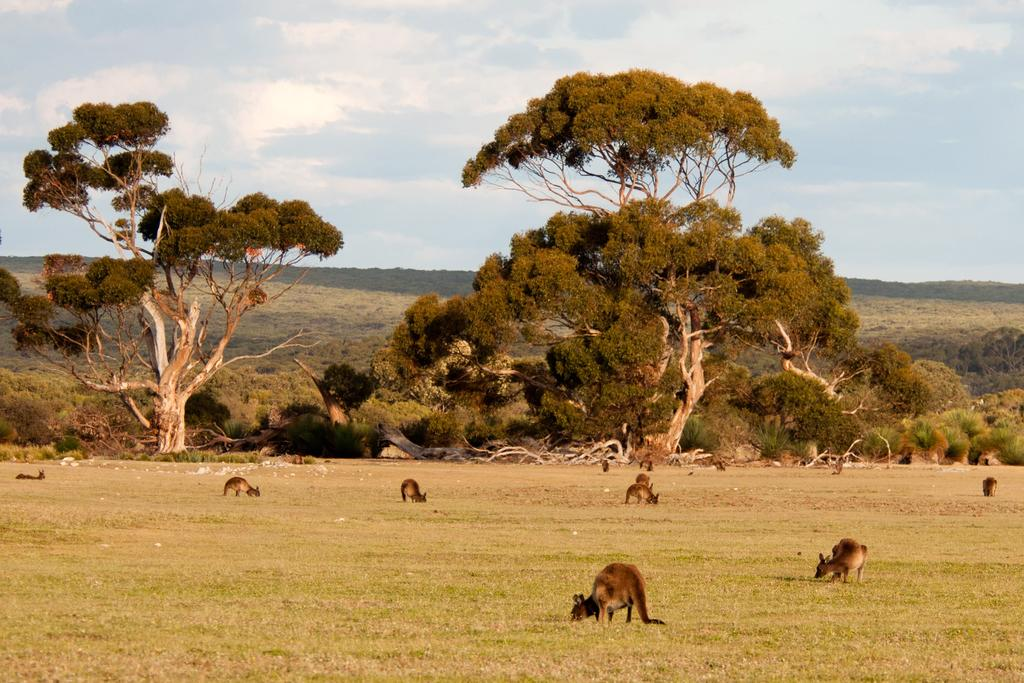What is the main subject of the image? There is a group of animals in the image. How are the animals positioned in the image? The animals are standing on the ground. What can be seen in the background of the image? There is a group of trees and mountains visible in the background, and the sky is cloudy. What type of haircut does the camera have in the image? There is no camera present in the image, and therefore no haircut can be observed. 